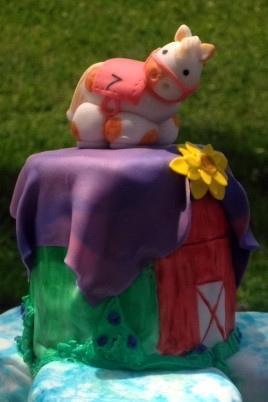How many characters are on the cake?
Give a very brief answer. 1. 